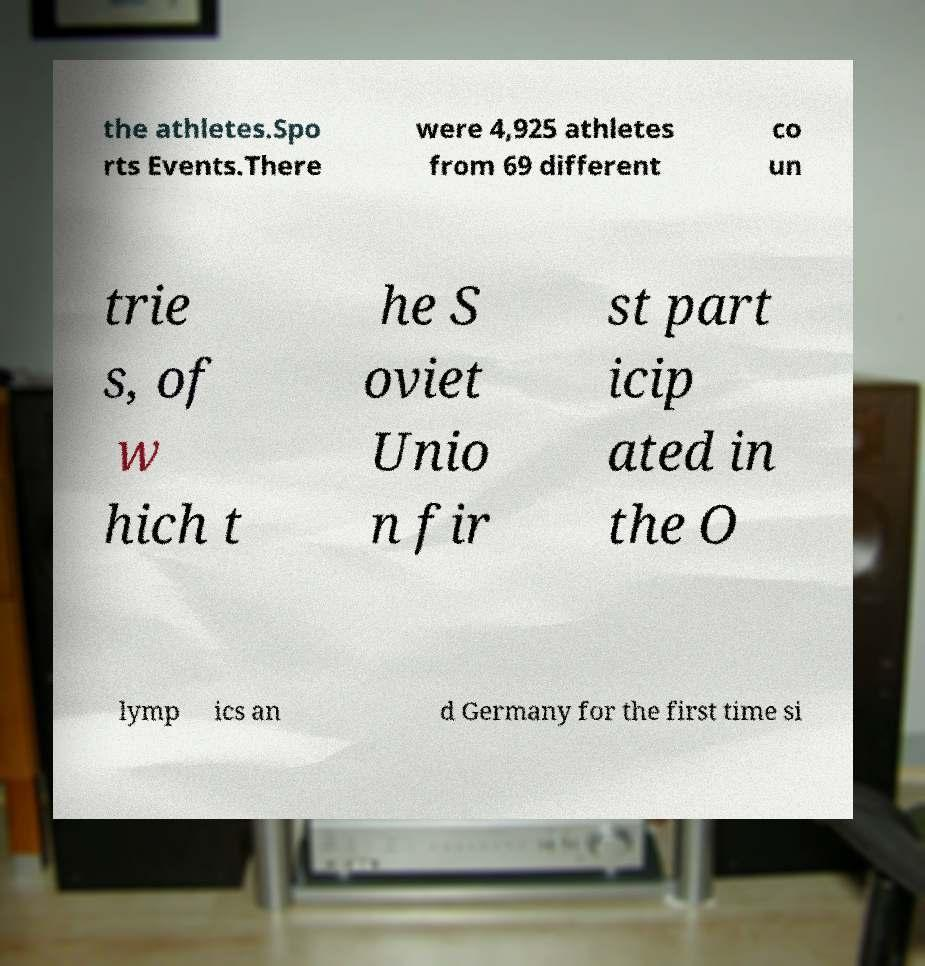Can you read and provide the text displayed in the image?This photo seems to have some interesting text. Can you extract and type it out for me? the athletes.Spo rts Events.There were 4,925 athletes from 69 different co un trie s, of w hich t he S oviet Unio n fir st part icip ated in the O lymp ics an d Germany for the first time si 